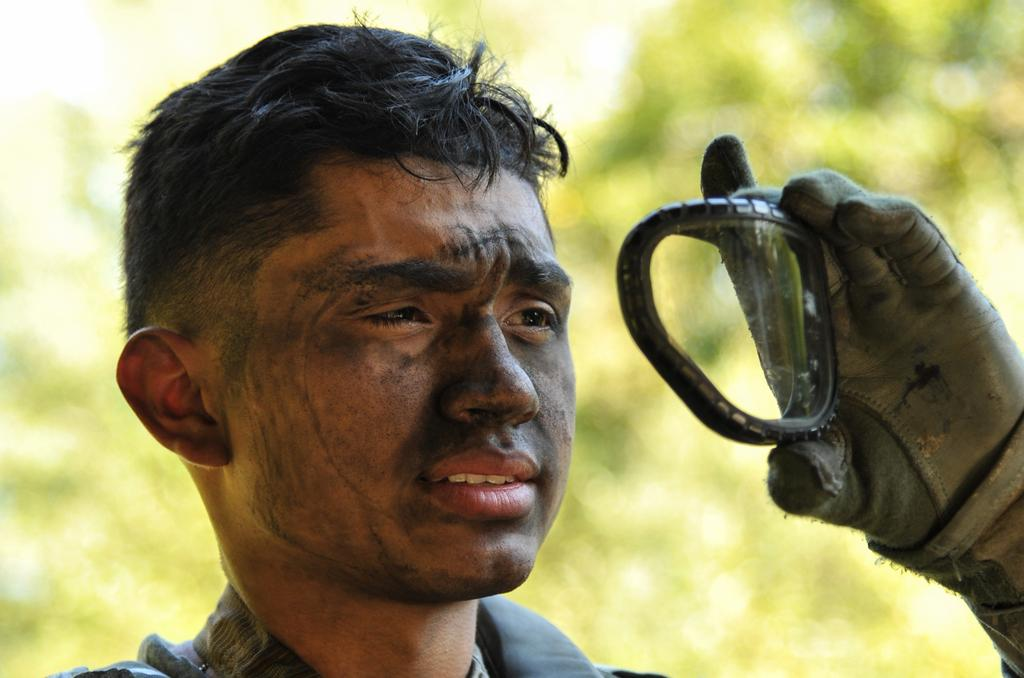What is the main subject of the image? There is a man in the image. What is the man doing in the image? The man is standing in the image. What is the man wearing on his hands? The man is wearing gloves in the image. What is the man holding in his hand? The man is holding an object in his hand in the image. What can be seen in the background of the image? There are trees visible in the background of the image. What type of mint can be seen growing near the man in the image? There is no mint present in the image; only the man, trees, and the object he is holding can be seen. 